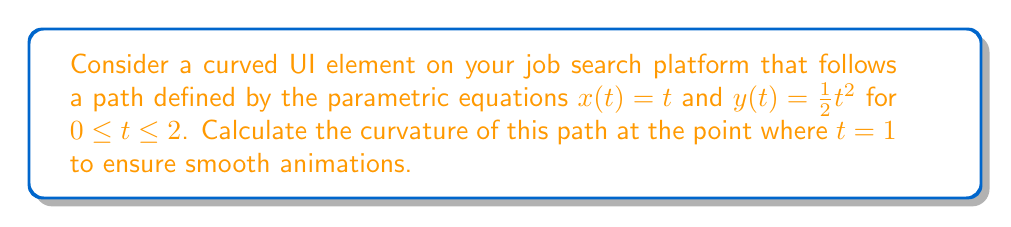Provide a solution to this math problem. To calculate the curvature of the UI element's path, we'll follow these steps:

1) The curvature $\kappa$ of a parametric curve is given by:

   $$\kappa = \frac{|x'y'' - y'x''|}{(x'^2 + y'^2)^{3/2}}$$

2) First, we need to find $x'(t)$, $y'(t)$, $x''(t)$, and $y''(t)$:
   
   $x'(t) = 1$
   $y'(t) = t$
   $x''(t) = 0$
   $y''(t) = 1$

3) Now, let's substitute these values into the curvature formula:

   $$\kappa = \frac{|x'y'' - y'x''|}{(x'^2 + y'^2)^{3/2}}$$
   $$= \frac{|1 \cdot 1 - t \cdot 0|}{(1^2 + t^2)^{3/2}}$$
   $$= \frac{1}{(1 + t^2)^{3/2}}$$

4) We want to find the curvature at $t = 1$, so let's substitute this value:

   $$\kappa_{t=1} = \frac{1}{(1 + 1^2)^{3/2}}$$
   $$= \frac{1}{2^{3/2}}$$
   $$= \frac{1}{2\sqrt{2}}$$

This curvature value will help ensure smooth animations for the UI element along its path.
Answer: $\frac{1}{2\sqrt{2}}$ 